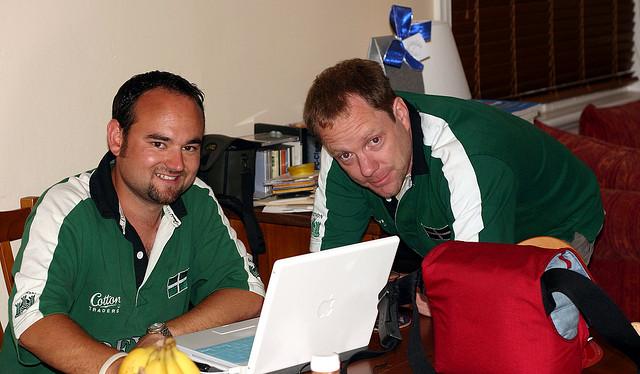Are there bananas nearby?
Short answer required. Yes. Do there shirts match?
Quick response, please. Yes. Are the people teammates?
Answer briefly. Yes. Are they wearing matching shirts?
Keep it brief. Yes. Does the man on the far left have a beard?
Be succinct. Yes. 